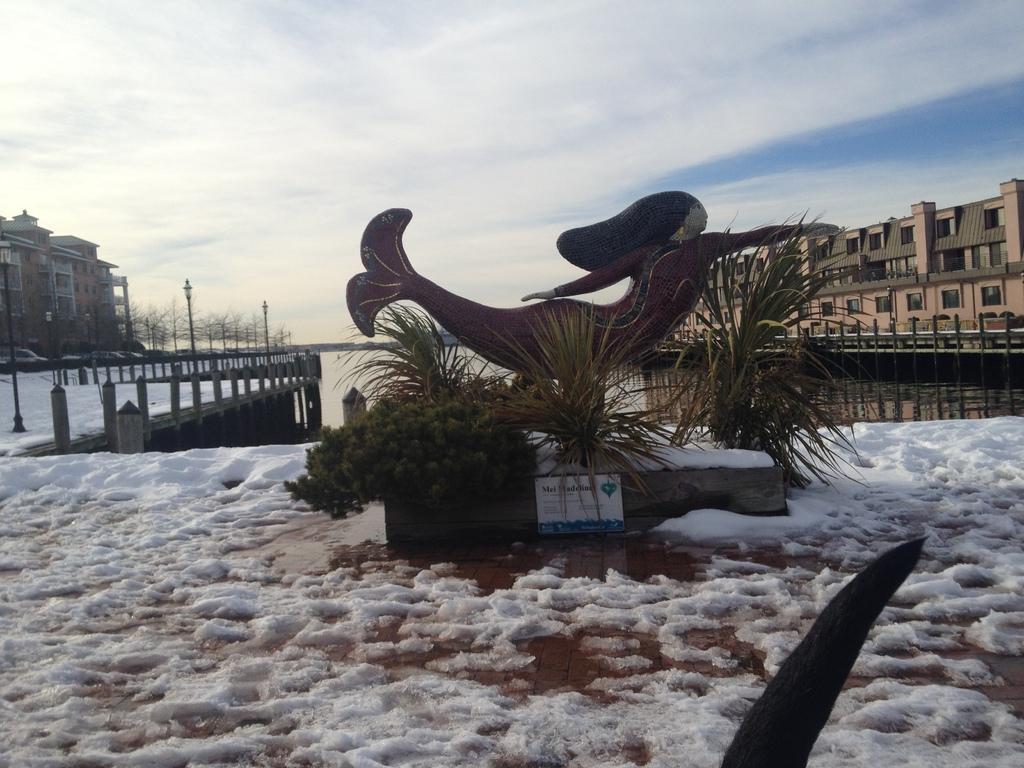Could you give a brief overview of what you see in this image? In this picture we can observe a statue of a half woman and half fish. There are some plants. We can observe snow on the ground. In the background there is a river. We can observe buildings and poles. There is a sky with clouds. 